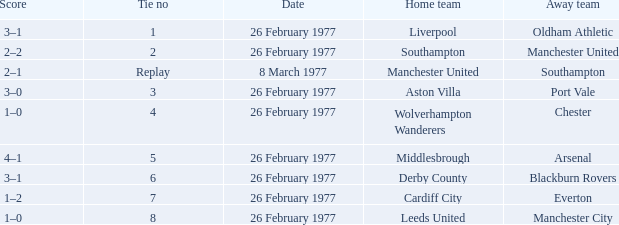What was the score when the tie game was replayed? 2–1. 